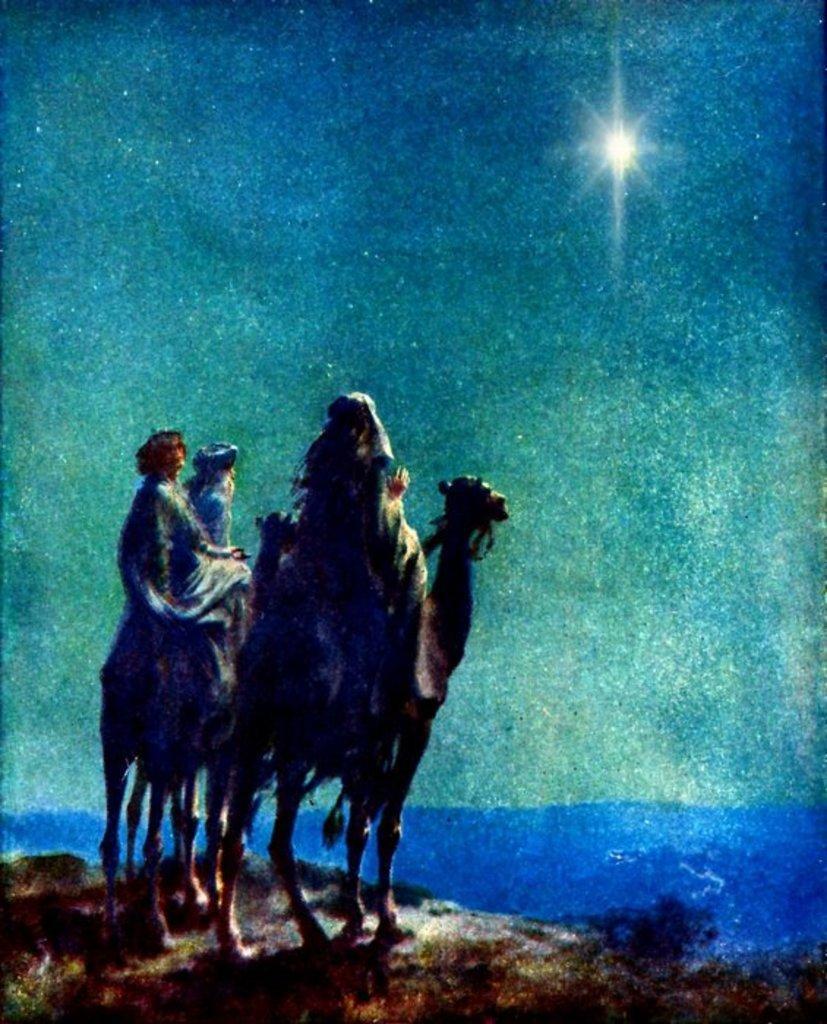Please provide a concise description of this image. In this picture we can see a painting, in the painting we can find few camels and group of people. 